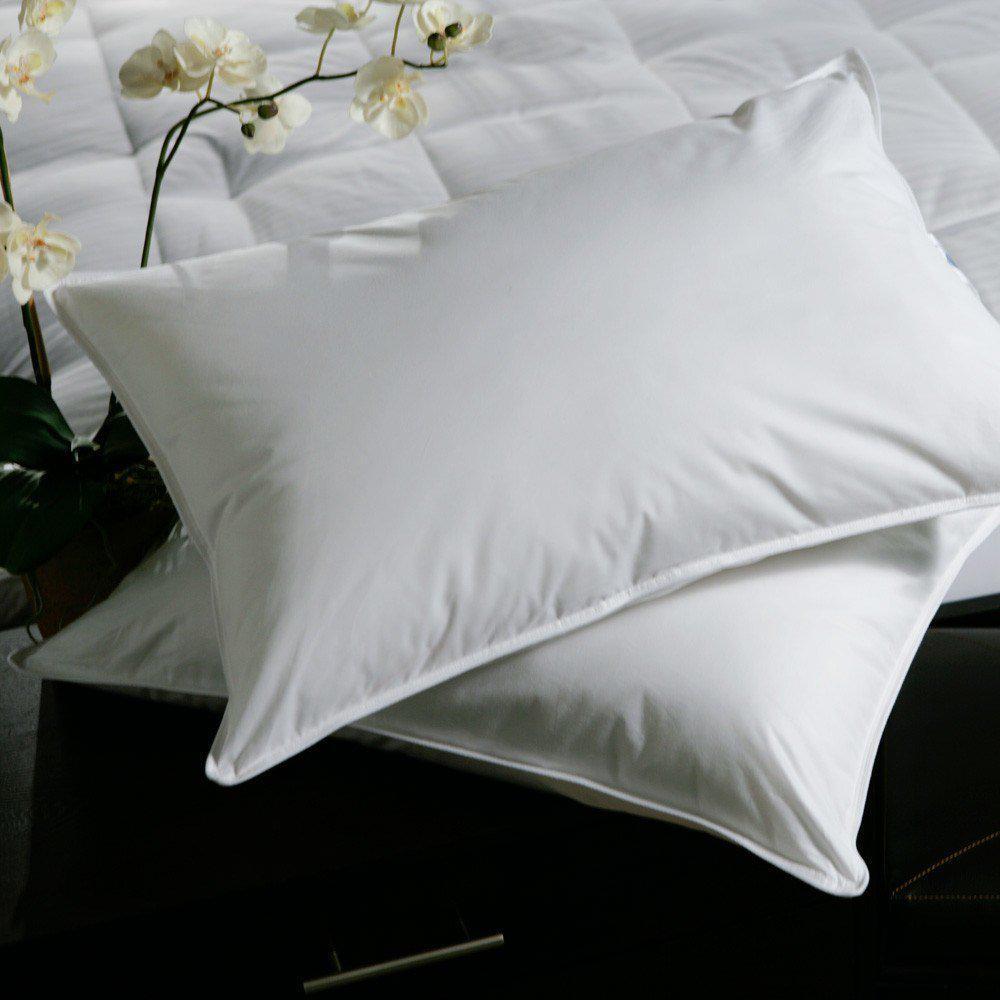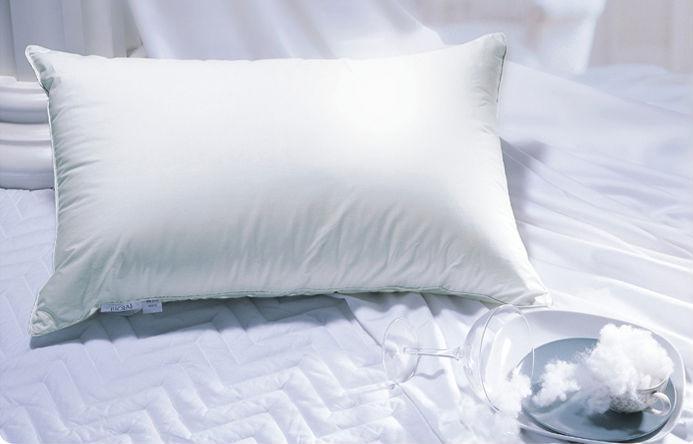The first image is the image on the left, the second image is the image on the right. Examine the images to the left and right. Is the description "There are three or fewer pillows." accurate? Answer yes or no. Yes. 